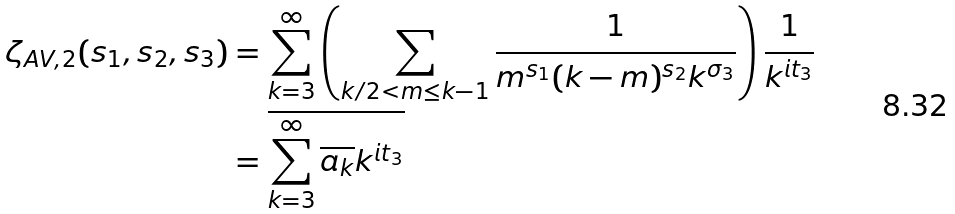Convert formula to latex. <formula><loc_0><loc_0><loc_500><loc_500>\zeta _ { A V , 2 } ( s _ { 1 } , s _ { 2 } , s _ { 3 } ) & = \sum _ { k = 3 } ^ { \infty } \left ( \sum _ { k / 2 < m \leq k - 1 } \frac { 1 } { m ^ { s _ { 1 } } ( k - m ) ^ { s _ { 2 } } k ^ { \sigma _ { 3 } } } \right ) \frac { 1 } { k ^ { i t _ { 3 } } } \\ & = \overline { \sum _ { k = 3 } ^ { \infty } \overline { a _ { k } } k ^ { i t _ { 3 } } } \\</formula> 